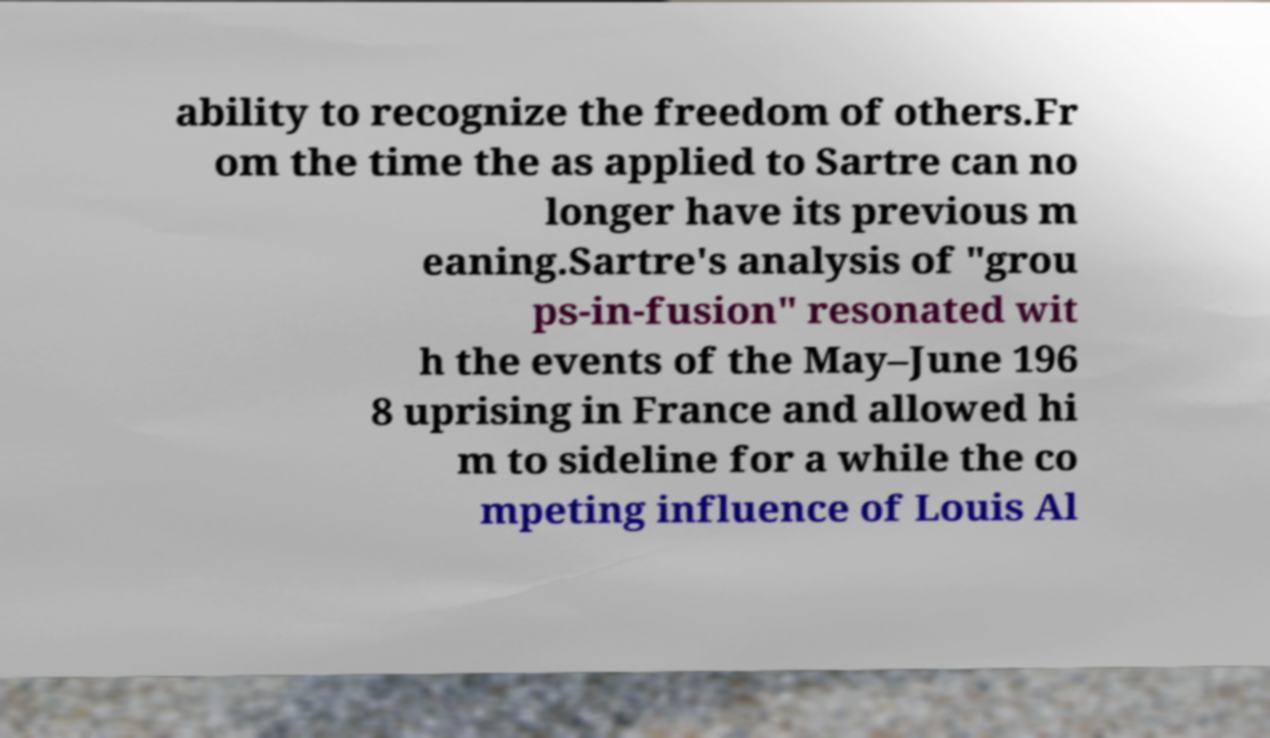Can you read and provide the text displayed in the image?This photo seems to have some interesting text. Can you extract and type it out for me? ability to recognize the freedom of others.Fr om the time the as applied to Sartre can no longer have its previous m eaning.Sartre's analysis of "grou ps-in-fusion" resonated wit h the events of the May–June 196 8 uprising in France and allowed hi m to sideline for a while the co mpeting influence of Louis Al 